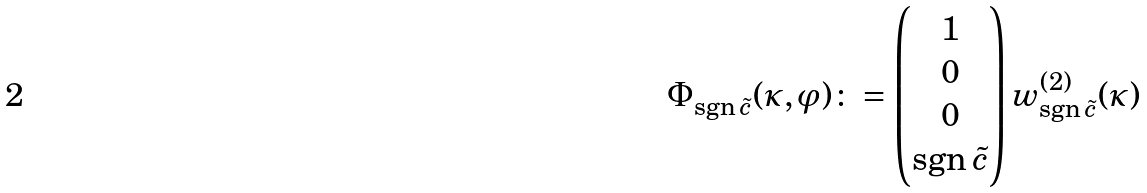<formula> <loc_0><loc_0><loc_500><loc_500>\Phi ^ { \ } _ { \text {sgn} \, \tilde { c } } ( \kappa , \varphi ) \colon = \begin{pmatrix} 1 \\ 0 \\ 0 \\ \text {sgn} \, \tilde { c } \end{pmatrix} w ^ { ( 2 ) } _ { \text {sgn} \, \tilde { c } } ( \kappa )</formula> 